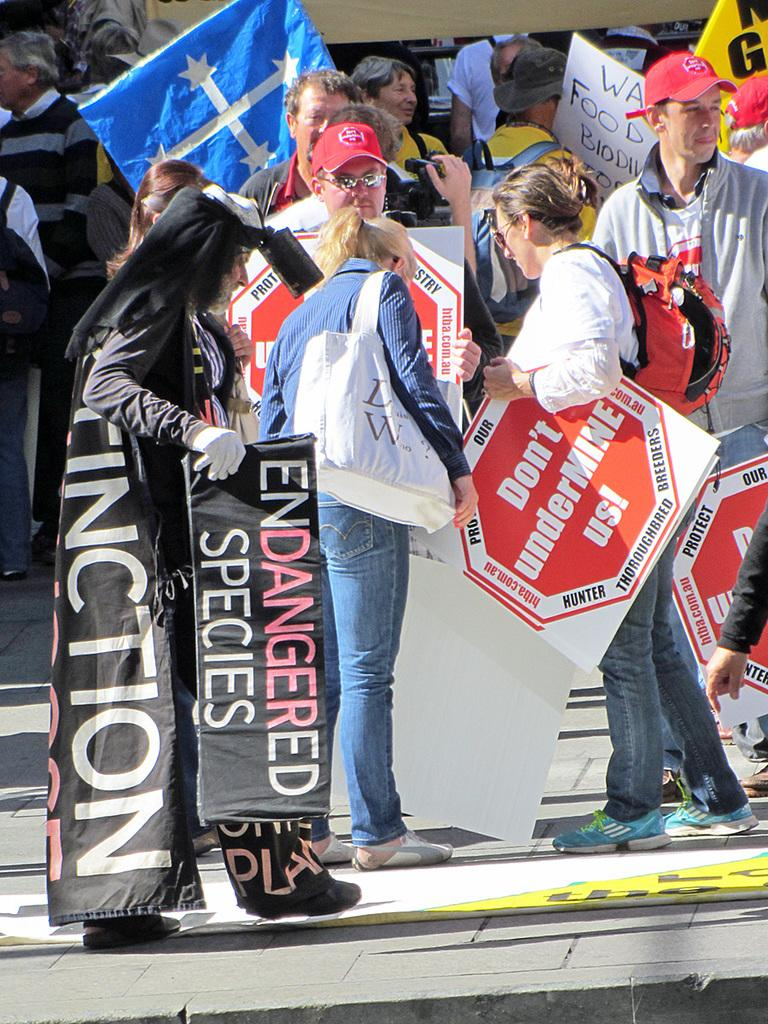What is happening with the group of people in the image? There is a group of people on the ground in the image. What are some of the people in the group doing? Some people in the group are holding posters. What can be seen in the background of the image? There are objects visible in the background of the image. What note is being played by the people in the image? There is no indication of music or notes being played in the image; it features a group of people holding posters. What profit is being made by the people in the image? There is no mention of profit or financial gain in the image; it simply shows a group of people holding posters. 